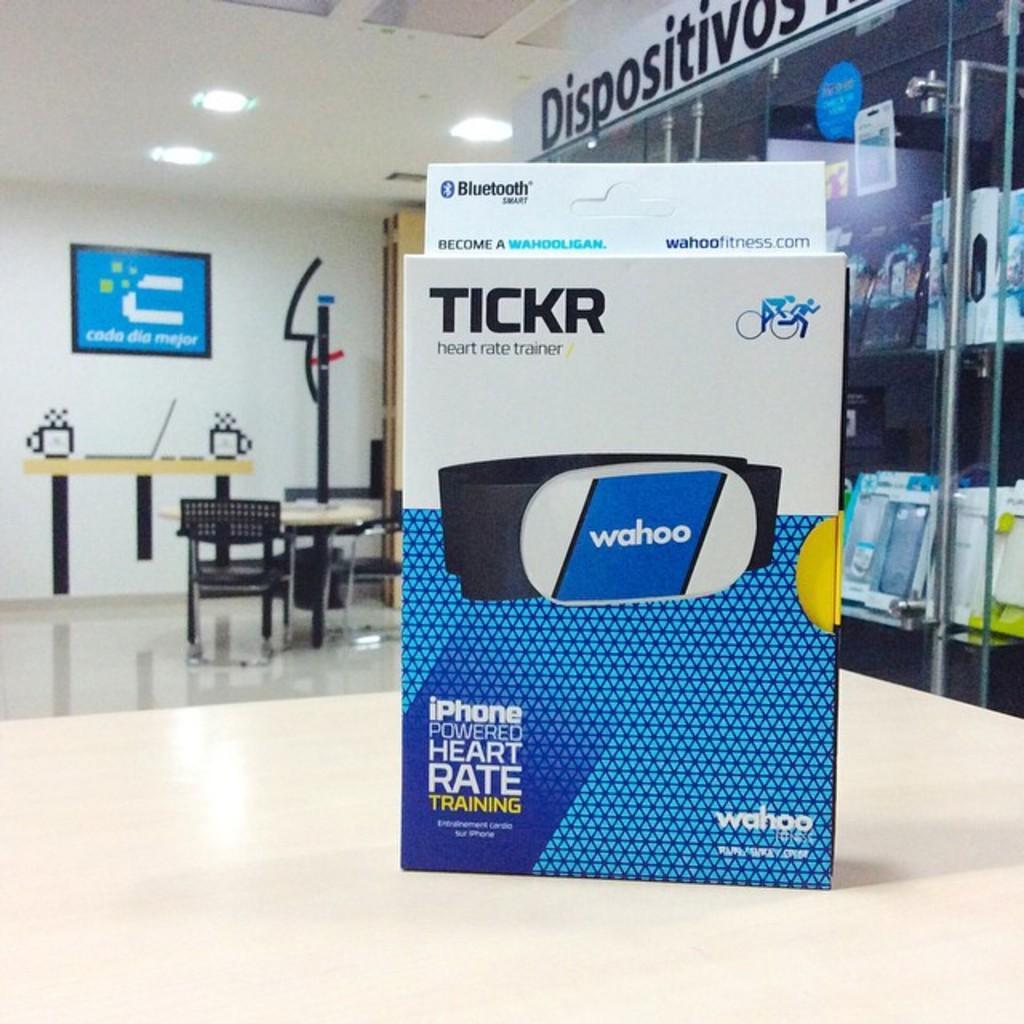Describe this image in one or two sentences. In this image, we can see some chairs, tables with some objects. We can see some posters with text and images. We can see the wall with some objects. We can see some glass. We can see some shelves with objects. We can see some text. 